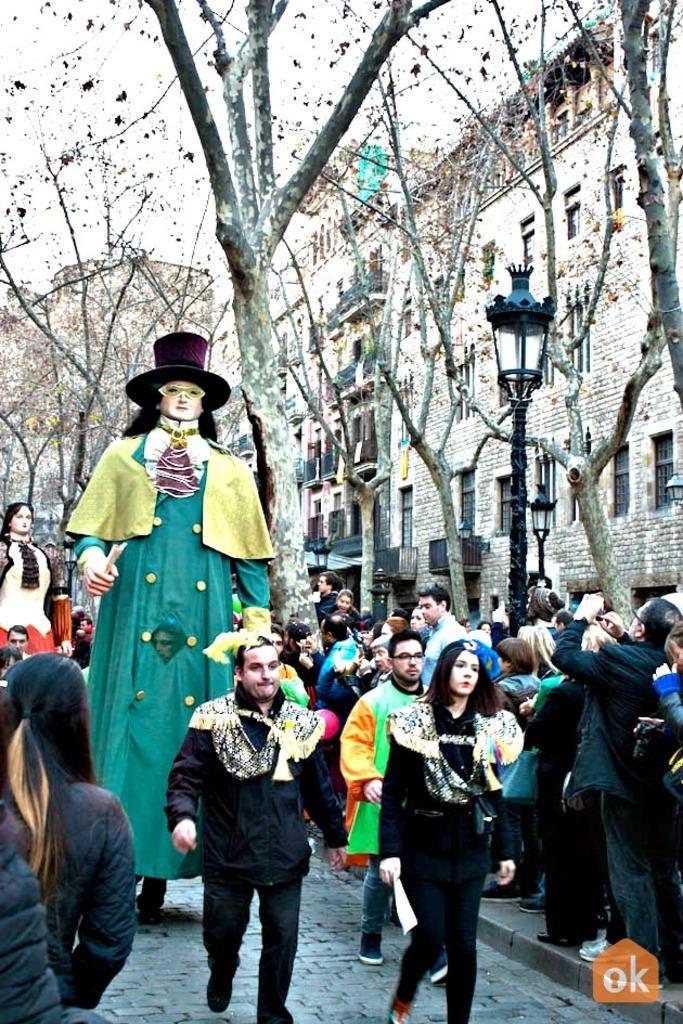Please provide a concise description of this image. There is a road. On the road there are many people. Also there are costumes. On the costume there's hat. In the back there are trees and buildings with windows. Also there is a light pole. In the right bottom corner there is a watermark. 